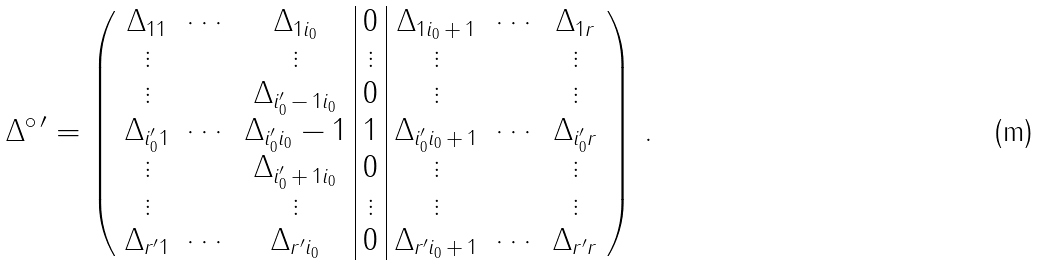<formula> <loc_0><loc_0><loc_500><loc_500>\Delta ^ { \circ \, \prime } = \left ( \begin{array} { c c c | c | c c c } \Delta _ { 1 1 } & \cdots & \Delta _ { 1 i _ { 0 } } & 0 & \Delta _ { 1 i _ { 0 } \, + \, 1 } & \cdots & \Delta _ { 1 r } \\ \vdots & & \vdots & \vdots & \vdots & & \vdots \\ \vdots & & \Delta _ { i _ { 0 } ^ { \prime } \, - \, 1 i _ { 0 } } & 0 & \vdots & & \vdots \\ \Delta _ { i _ { 0 } ^ { \prime } 1 } & \cdots & \Delta _ { i _ { 0 } ^ { \prime } i _ { 0 } } - 1 & 1 & \Delta _ { i _ { 0 } ^ { \prime } i _ { 0 } \, + \, 1 } & \cdots & \Delta _ { i _ { 0 } ^ { \prime } r } \\ \vdots & & \Delta _ { i _ { 0 } ^ { \prime } \, + \, 1 i _ { 0 } } & 0 & \vdots & & \vdots \\ \vdots & & \vdots & \vdots & \vdots & & \vdots \\ \Delta _ { r ^ { \prime } 1 } & \cdots & \Delta _ { r ^ { \prime } i _ { 0 } } & 0 & \Delta _ { r ^ { \prime } i _ { 0 } \, + \, 1 } & \cdots & \Delta _ { r ^ { \prime } r } \end{array} \right ) \, .</formula> 